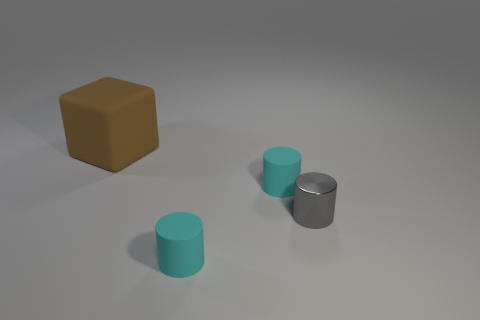There is a brown thing that is behind the gray thing; does it have the same shape as the small cyan object behind the metallic object?
Your answer should be compact. No. What color is the thing that is to the right of the big cube and behind the gray thing?
Your response must be concise. Cyan. There is a large block; is its color the same as the small cylinder in front of the small gray object?
Ensure brevity in your answer.  No. What size is the rubber object that is both in front of the large thing and behind the gray object?
Your answer should be compact. Small. How many other things are there of the same color as the large object?
Provide a succinct answer. 0. There is a cyan cylinder that is in front of the object to the right of the small cyan rubber cylinder that is behind the tiny metal cylinder; how big is it?
Make the answer very short. Small. There is a gray metal thing; are there any small cyan things behind it?
Your answer should be very brief. Yes. Do the metallic thing and the cyan matte object that is behind the gray shiny cylinder have the same size?
Provide a short and direct response. Yes. How many other objects are the same material as the gray cylinder?
Offer a very short reply. 0. What is the shape of the object that is both behind the gray metal object and in front of the large rubber object?
Make the answer very short. Cylinder. 